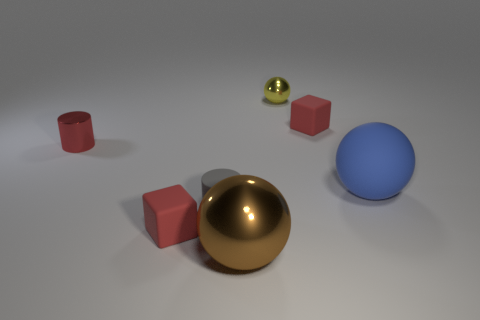Add 2 yellow metal spheres. How many objects exist? 9 Subtract all cubes. How many objects are left? 5 Add 6 metallic balls. How many metallic balls are left? 8 Add 6 tiny metal objects. How many tiny metal objects exist? 8 Subtract 1 yellow balls. How many objects are left? 6 Subtract all green things. Subtract all tiny gray matte cylinders. How many objects are left? 6 